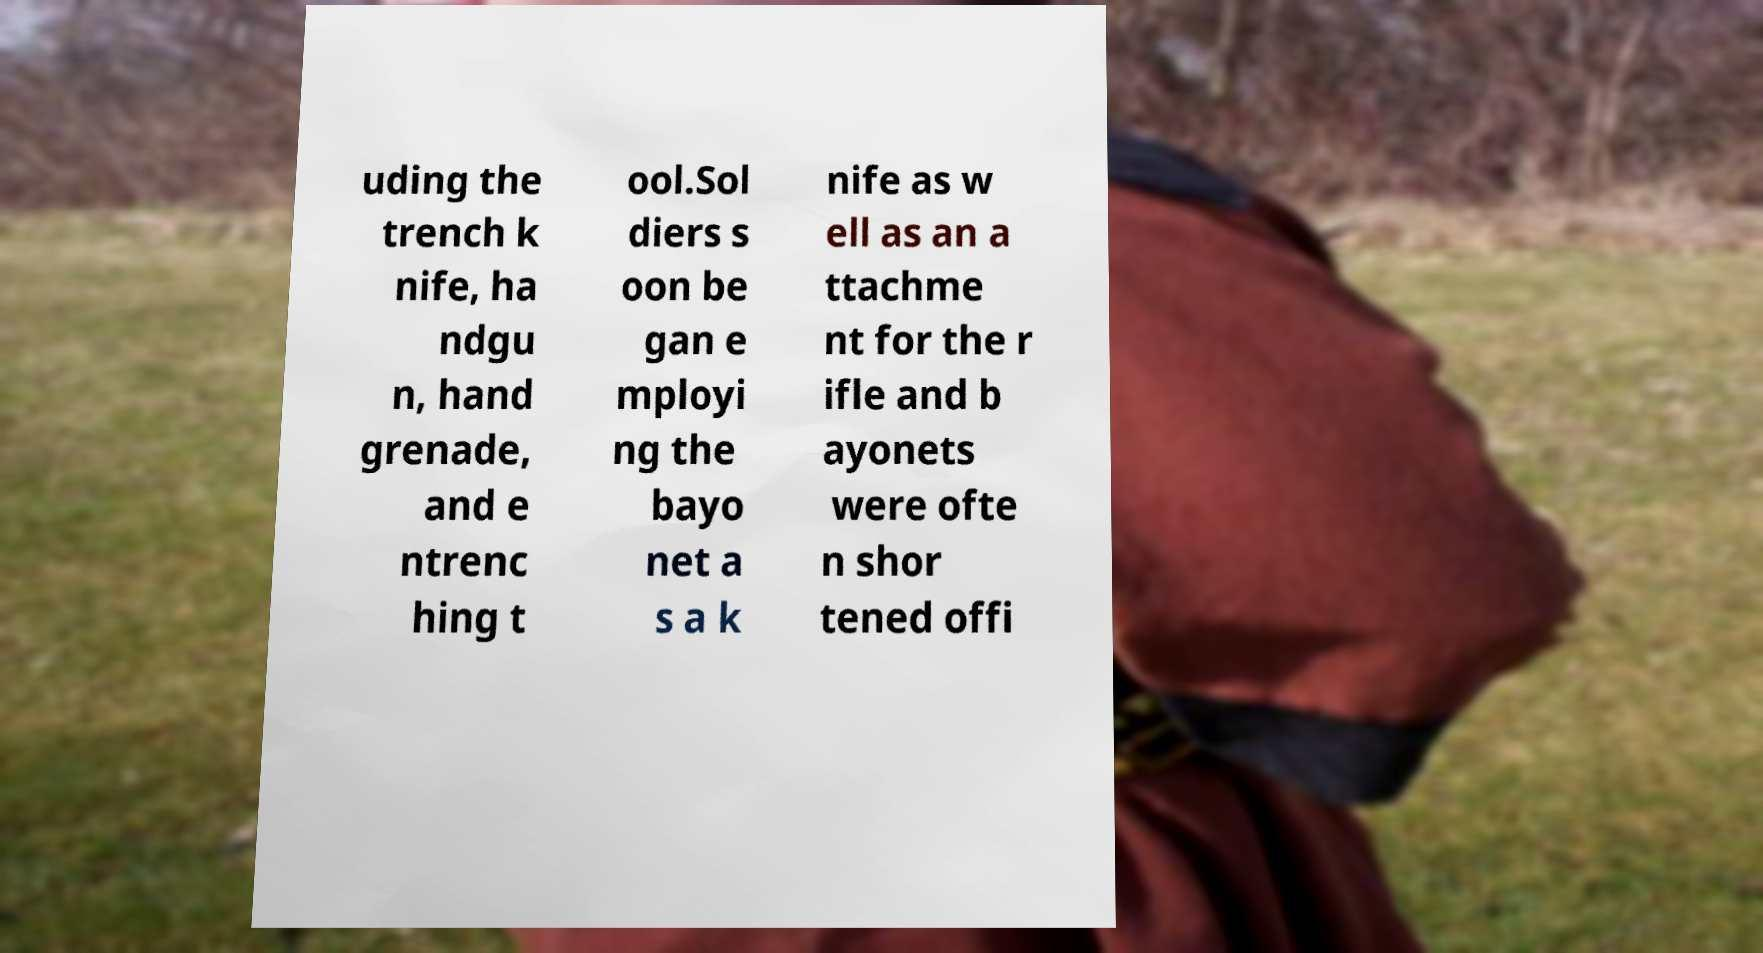Could you extract and type out the text from this image? uding the trench k nife, ha ndgu n, hand grenade, and e ntrenc hing t ool.Sol diers s oon be gan e mployi ng the bayo net a s a k nife as w ell as an a ttachme nt for the r ifle and b ayonets were ofte n shor tened offi 